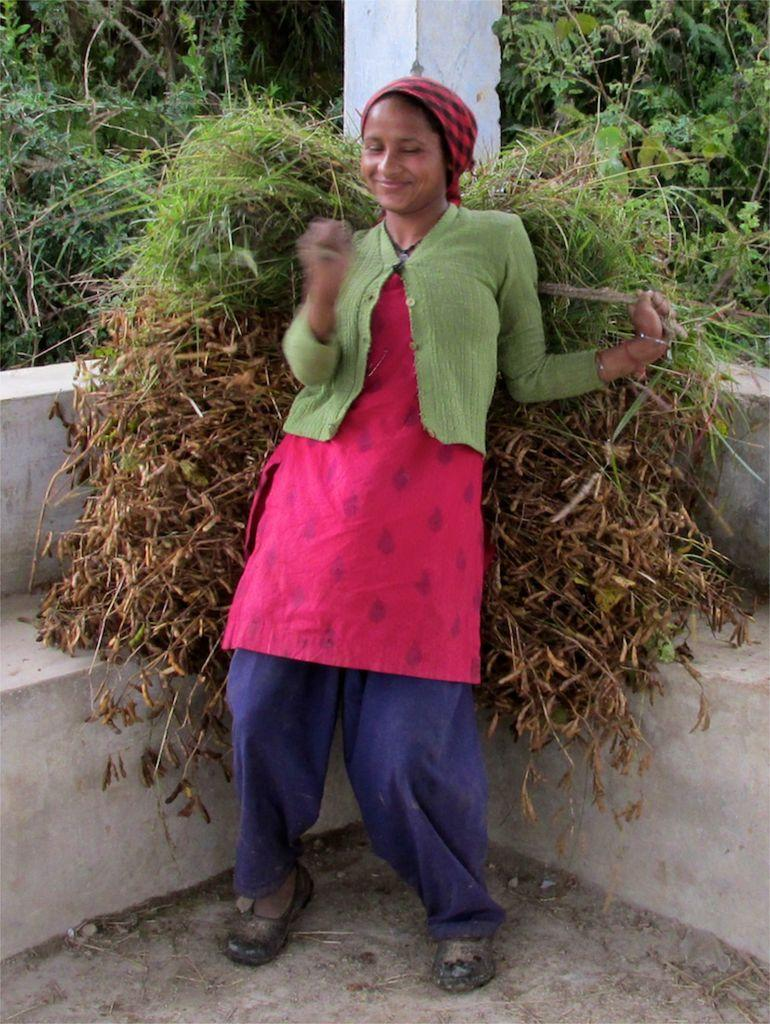Who is the main subject in the image? There is a woman standing in the center of the image. What can be seen in the background of the image? There are plants, grass, a pillar, and a wall in the background of the image. What is visible at the bottom of the image? There is a floor visible at the bottom of the image. What is present on the floor in the image? There are dry leaves on the floor. What type of honey is dripping from the pillar in the image? There is no honey present in the image, and therefore no honey dripping from the pillar. Can you tell me how many dogs are visible in the image? There are no dogs present in the image. 